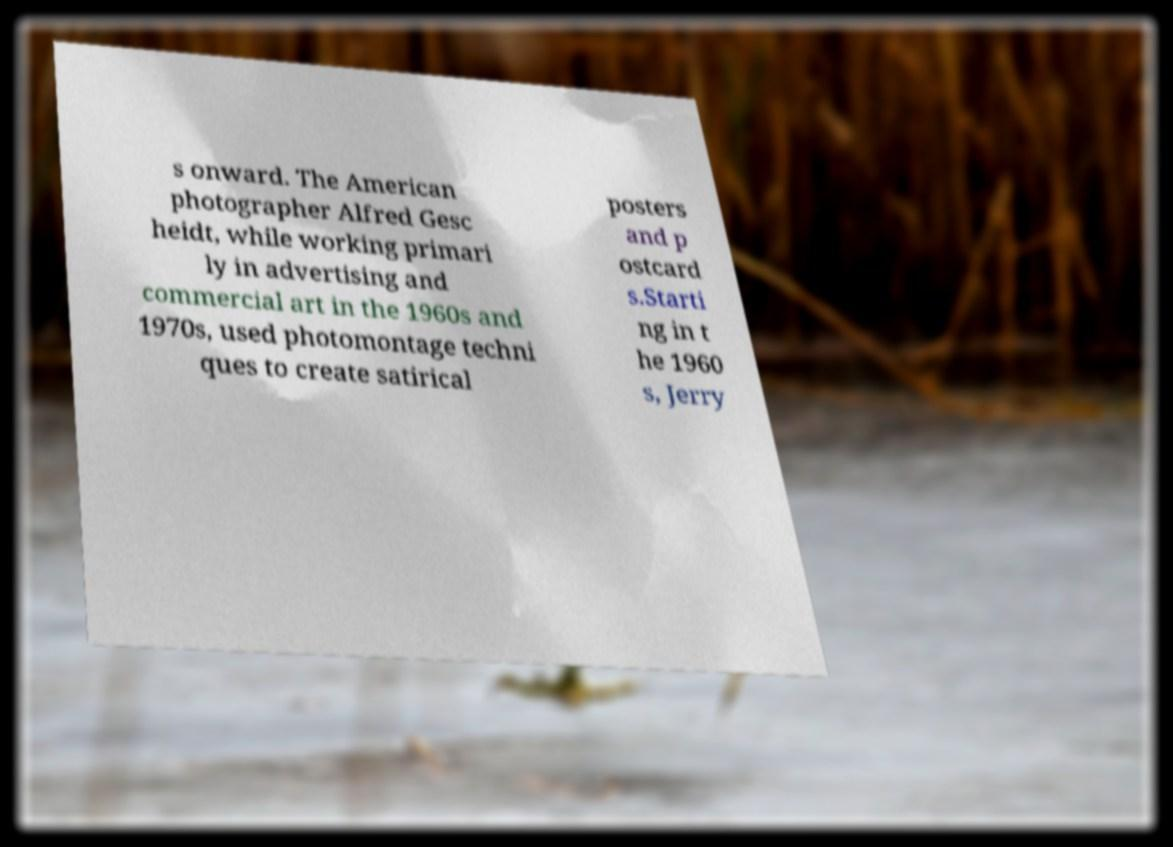Could you extract and type out the text from this image? s onward. The American photographer Alfred Gesc heidt, while working primari ly in advertising and commercial art in the 1960s and 1970s, used photomontage techni ques to create satirical posters and p ostcard s.Starti ng in t he 1960 s, Jerry 